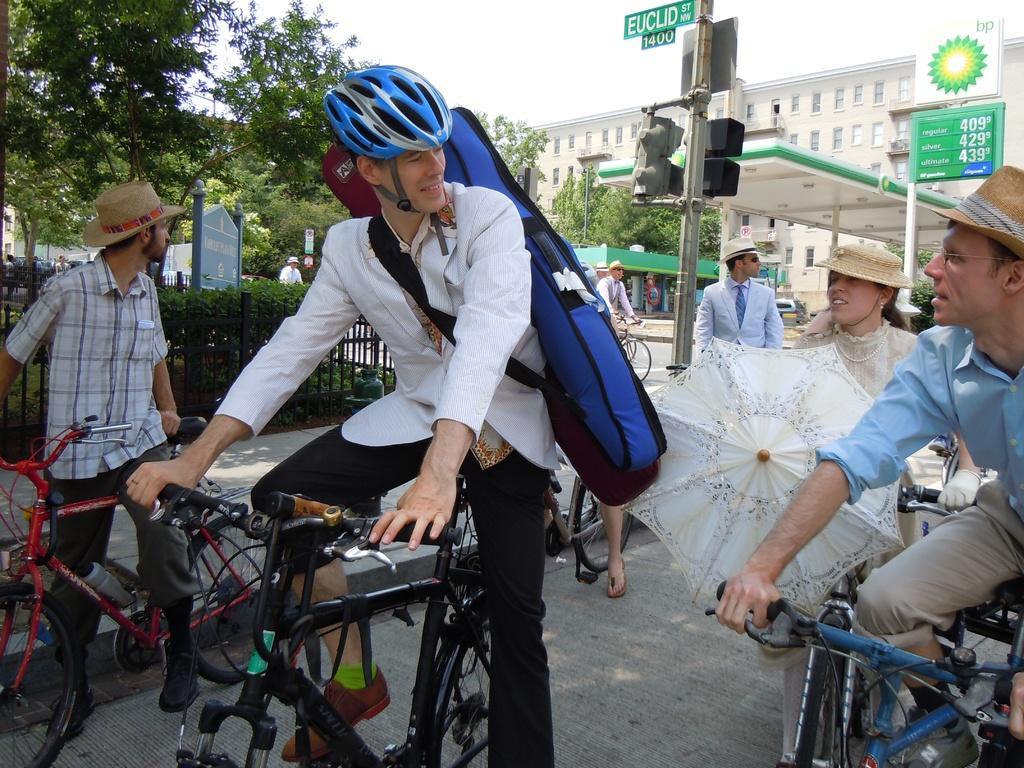In one or two sentences, can you explain what this image depicts? In this image i can see 3 persons riding a bicycle,a person in the middle is wearing a helmet and a bag. I can see a woman with an umbrella. In the background i can see few persons,traffic lights, trees and buildings. 